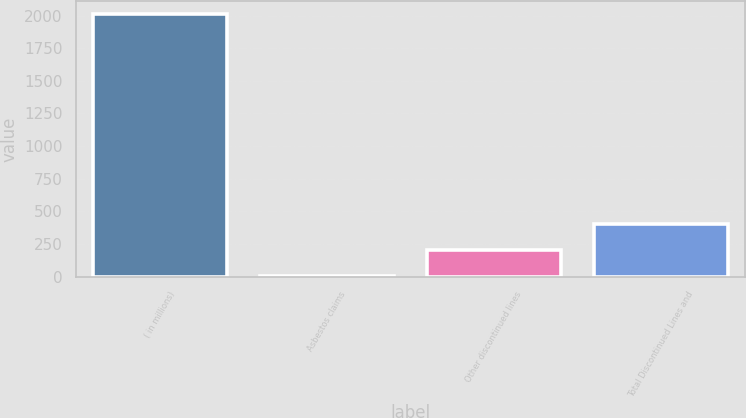Convert chart. <chart><loc_0><loc_0><loc_500><loc_500><bar_chart><fcel>( in millions)<fcel>Asbestos claims<fcel>Other discontinued lines<fcel>Total Discontinued Lines and<nl><fcel>2010<fcel>5<fcel>205.5<fcel>406<nl></chart> 